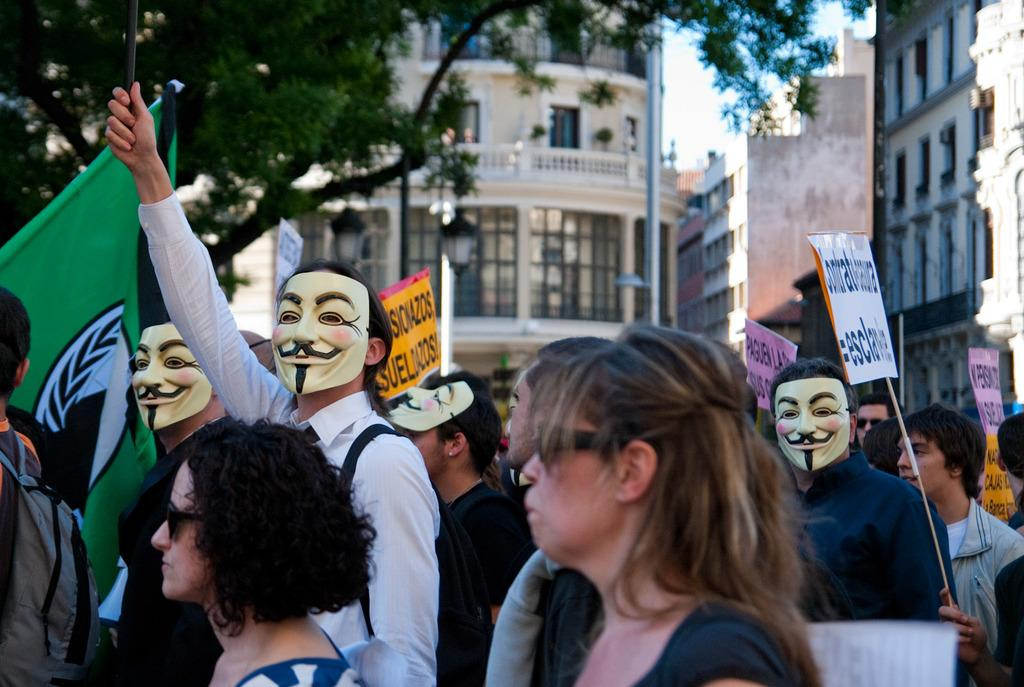How many people are in the group depicted in the image? There is a group of people in the image, but the exact number is not specified. What are some people in the group wearing? Some people in the group are wearing masks. What are some people in the group holding? Some people in the group are holding boards. What can be seen in the background of the image? There is a flag, a tree, and buildings in the background of the image. What type of sound can be heard coming from the bears in the image? There are no bears present in the image, so it is not possible to determine what sound they might be making. 